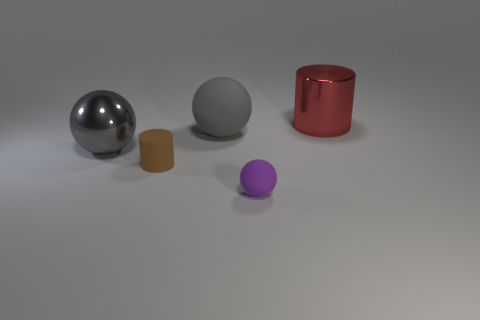Is there a metallic cylinder that has the same size as the gray matte sphere?
Make the answer very short. Yes. What is the size of the ball that is the same color as the large matte object?
Ensure brevity in your answer.  Large. There is a thing in front of the brown thing; what is its material?
Provide a succinct answer. Rubber. Are there the same number of objects that are behind the big gray matte ball and purple rubber spheres behind the big metallic cylinder?
Offer a terse response. No. Does the metal thing behind the gray matte object have the same size as the brown thing that is left of the large matte thing?
Your answer should be compact. No. How many small matte objects are the same color as the tiny matte ball?
Give a very brief answer. 0. There is another object that is the same color as the big matte thing; what material is it?
Your answer should be compact. Metal. Is the number of red cylinders that are on the left side of the small brown cylinder greater than the number of big red cylinders?
Ensure brevity in your answer.  No. Does the big matte object have the same shape as the big red object?
Provide a succinct answer. No. How many purple balls have the same material as the brown cylinder?
Your response must be concise. 1. 